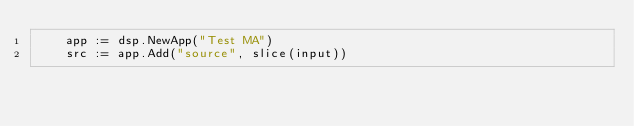<code> <loc_0><loc_0><loc_500><loc_500><_Go_>	app := dsp.NewApp("Test MA")
	src := app.Add("source", slice(input))</code> 